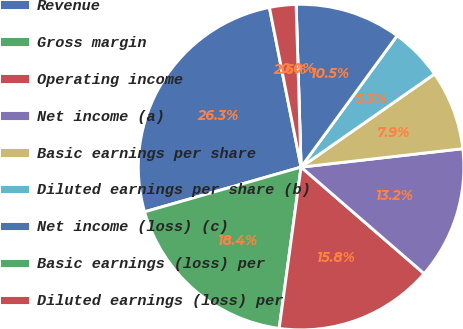Convert chart to OTSL. <chart><loc_0><loc_0><loc_500><loc_500><pie_chart><fcel>Revenue<fcel>Gross margin<fcel>Operating income<fcel>Net income (a)<fcel>Basic earnings per share<fcel>Diluted earnings per share (b)<fcel>Net income (loss) (c)<fcel>Basic earnings (loss) per<fcel>Diluted earnings (loss) per<nl><fcel>26.31%<fcel>18.42%<fcel>15.79%<fcel>13.16%<fcel>7.89%<fcel>5.26%<fcel>10.53%<fcel>0.0%<fcel>2.63%<nl></chart> 